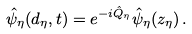<formula> <loc_0><loc_0><loc_500><loc_500>\hat { \psi } _ { \eta } ( d _ { \eta } , t ) = e ^ { - i \hat { Q } _ { \eta } } \hat { \psi } _ { \eta } ( z _ { \eta } ) \, .</formula> 